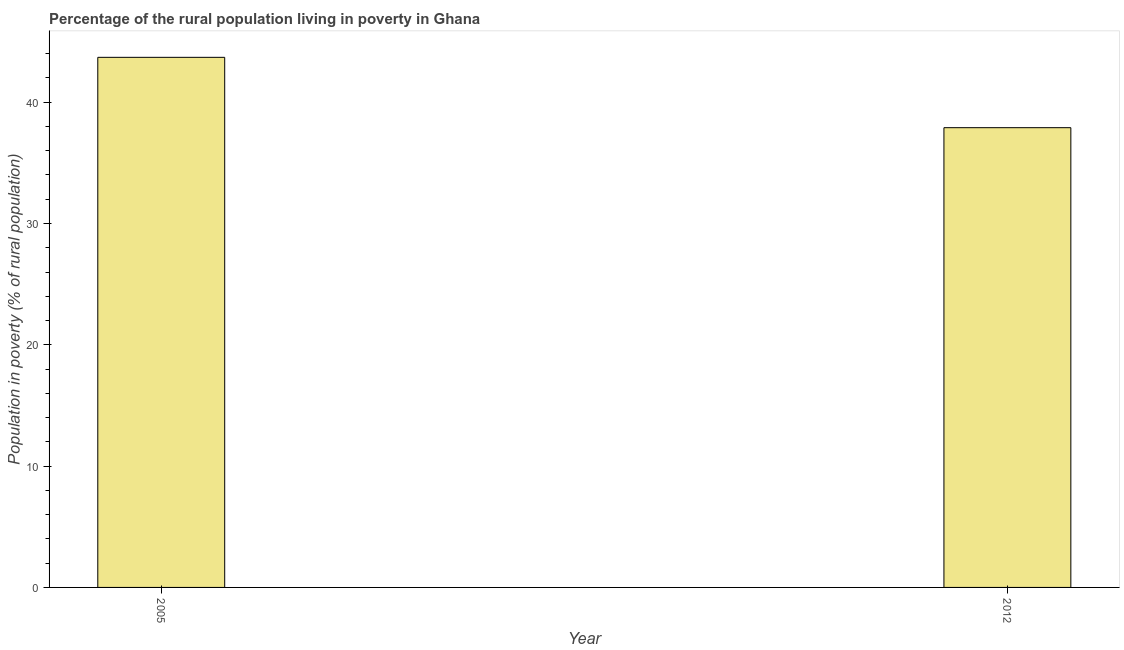Does the graph contain any zero values?
Provide a short and direct response. No. What is the title of the graph?
Offer a very short reply. Percentage of the rural population living in poverty in Ghana. What is the label or title of the Y-axis?
Your answer should be compact. Population in poverty (% of rural population). What is the percentage of rural population living below poverty line in 2005?
Keep it short and to the point. 43.7. Across all years, what is the maximum percentage of rural population living below poverty line?
Offer a very short reply. 43.7. Across all years, what is the minimum percentage of rural population living below poverty line?
Offer a terse response. 37.9. In which year was the percentage of rural population living below poverty line minimum?
Ensure brevity in your answer.  2012. What is the sum of the percentage of rural population living below poverty line?
Your answer should be very brief. 81.6. What is the difference between the percentage of rural population living below poverty line in 2005 and 2012?
Provide a short and direct response. 5.8. What is the average percentage of rural population living below poverty line per year?
Provide a short and direct response. 40.8. What is the median percentage of rural population living below poverty line?
Make the answer very short. 40.8. In how many years, is the percentage of rural population living below poverty line greater than 32 %?
Ensure brevity in your answer.  2. What is the ratio of the percentage of rural population living below poverty line in 2005 to that in 2012?
Your answer should be very brief. 1.15. Is the percentage of rural population living below poverty line in 2005 less than that in 2012?
Provide a short and direct response. No. How many bars are there?
Offer a terse response. 2. How many years are there in the graph?
Provide a succinct answer. 2. What is the Population in poverty (% of rural population) of 2005?
Provide a short and direct response. 43.7. What is the Population in poverty (% of rural population) of 2012?
Your answer should be very brief. 37.9. What is the ratio of the Population in poverty (% of rural population) in 2005 to that in 2012?
Your answer should be compact. 1.15. 